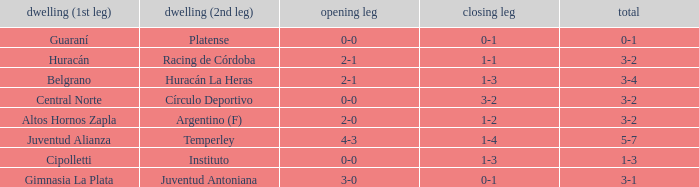Which team played the 2nd leg at home with a tie of 1-1 and scored 3-2 in aggregate? Racing de Córdoba. 